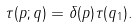Convert formula to latex. <formula><loc_0><loc_0><loc_500><loc_500>\tau ( p ; q ) = \delta ( p ) \tau ( q _ { 1 } ) .</formula> 